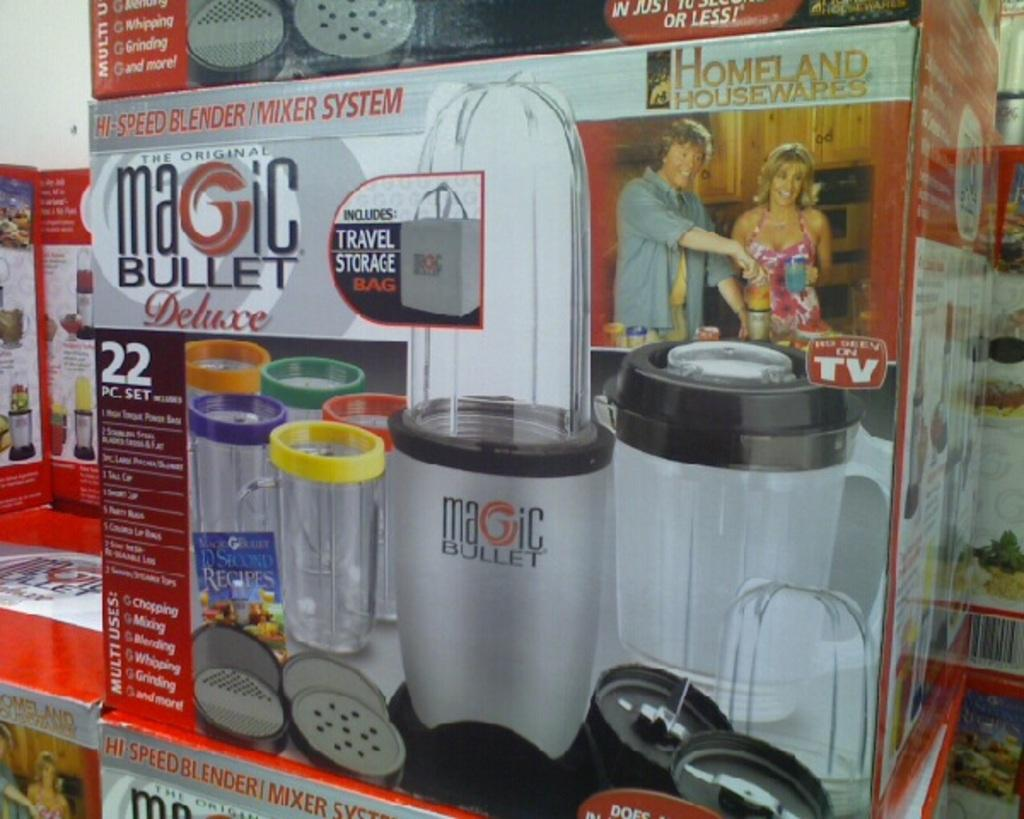<image>
Share a concise interpretation of the image provided. A box for the Magic Bullet Deluxe 22 pc. set is shown. 